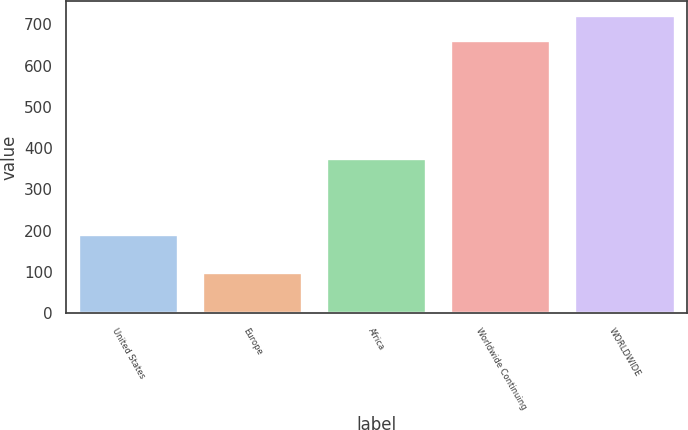<chart> <loc_0><loc_0><loc_500><loc_500><bar_chart><fcel>United States<fcel>Europe<fcel>Africa<fcel>Worldwide Continuing<fcel>WORLDWIDE<nl><fcel>189<fcel>98<fcel>373<fcel>660<fcel>720.6<nl></chart> 